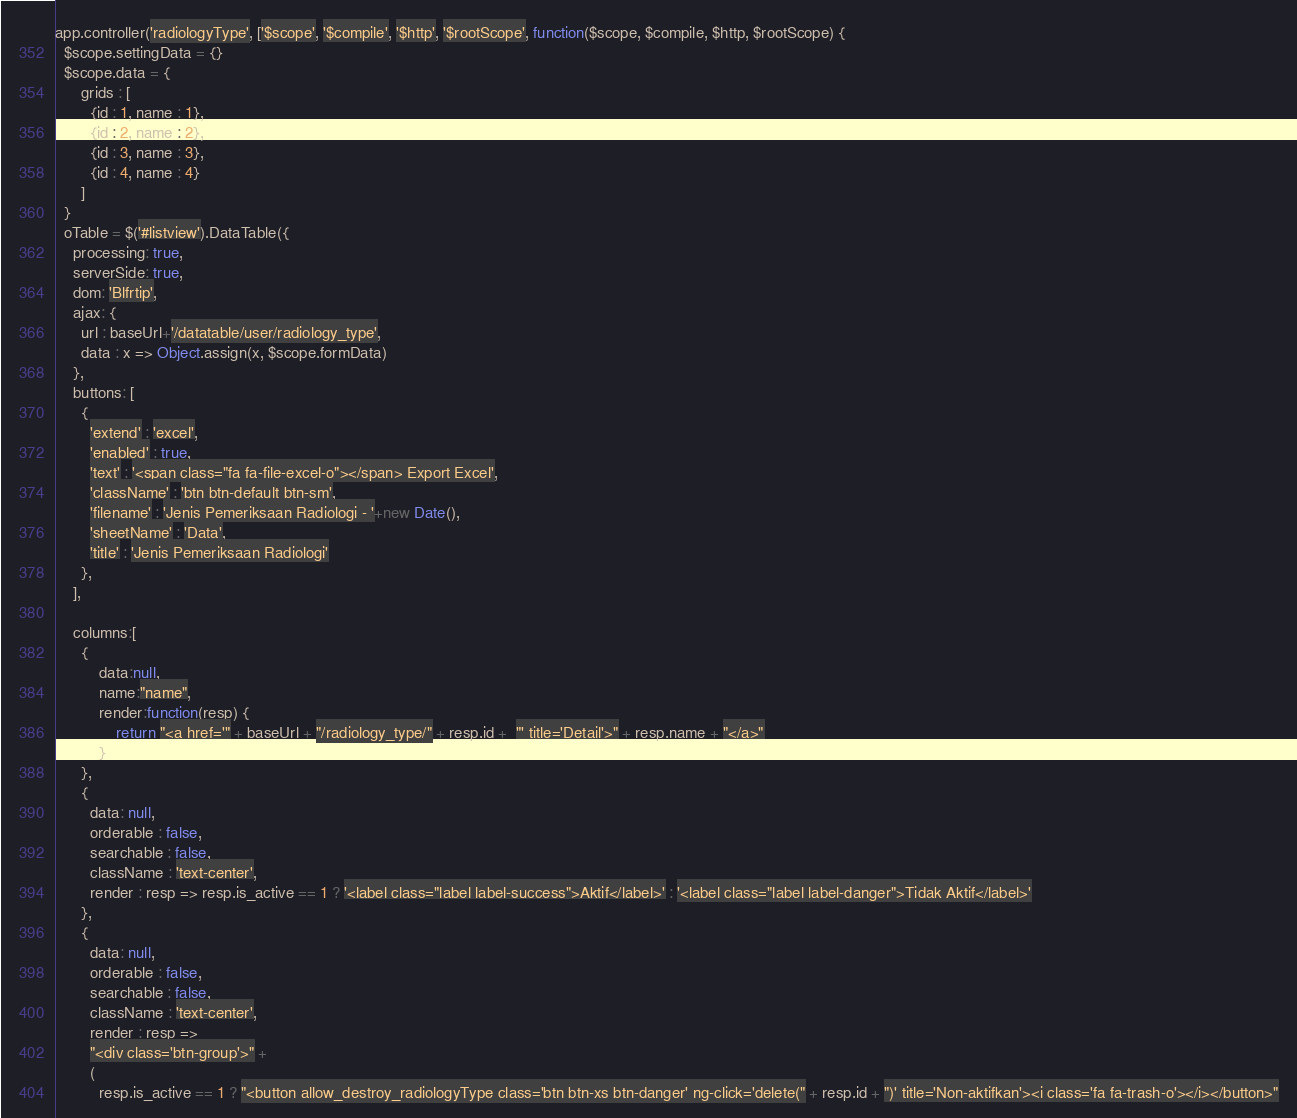Convert code to text. <code><loc_0><loc_0><loc_500><loc_500><_JavaScript_>app.controller('radiologyType', ['$scope', '$compile', '$http', '$rootScope', function($scope, $compile, $http, $rootScope) {
  $scope.settingData = {}
  $scope.data = {
      grids : [
        {id : 1, name : 1},
        {id : 2, name : 2},
        {id : 3, name : 3},
        {id : 4, name : 4}
      ]
  }
  oTable = $('#listview').DataTable({
    processing: true,
    serverSide: true,
    dom: 'Blfrtip',
    ajax: {
      url : baseUrl+'/datatable/user/radiology_type',
      data : x => Object.assign(x, $scope.formData)
    },
    buttons: [
      {
        'extend' : 'excel',
        'enabled' : true,
        'text' : '<span class="fa fa-file-excel-o"></span> Export Excel',
        'className' : 'btn btn-default btn-sm',
        'filename' : 'Jenis Pemeriksaan Radiologi - '+new Date(),
        'sheetName' : 'Data',
        'title' : 'Jenis Pemeriksaan Radiologi'
      },
    ],

    columns:[
      {
          data:null, 
          name:"name",
          render:function(resp) {
              return "<a href='" + baseUrl + "/radiology_type/" + resp.id +  "' title='Detail'>" + resp.name + "</a>"
          }
      },
      {
        data: null, 
        orderable : false,
        searchable : false,
        className : 'text-center',
        render : resp => resp.is_active == 1 ? '<label class="label label-success">Aktif</label>' : '<label class="label label-danger">Tidak Aktif</label>'
      },
      {
        data: null, 
        orderable : false,
        searchable : false,
        className : 'text-center',
        render : resp => 
        "<div class='btn-group'>" + 
        ( 
          resp.is_active == 1 ? "<button allow_destroy_radiologyType class='btn btn-xs btn-danger' ng-click='delete(" + resp.id + ")' title='Non-aktifkan'><i class='fa fa-trash-o'></i></button>"</code> 